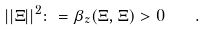Convert formula to latex. <formula><loc_0><loc_0><loc_500><loc_500>| | \Xi | | ^ { 2 } \colon = \beta _ { z } ( \Xi , \Xi ) > 0 \quad .</formula> 